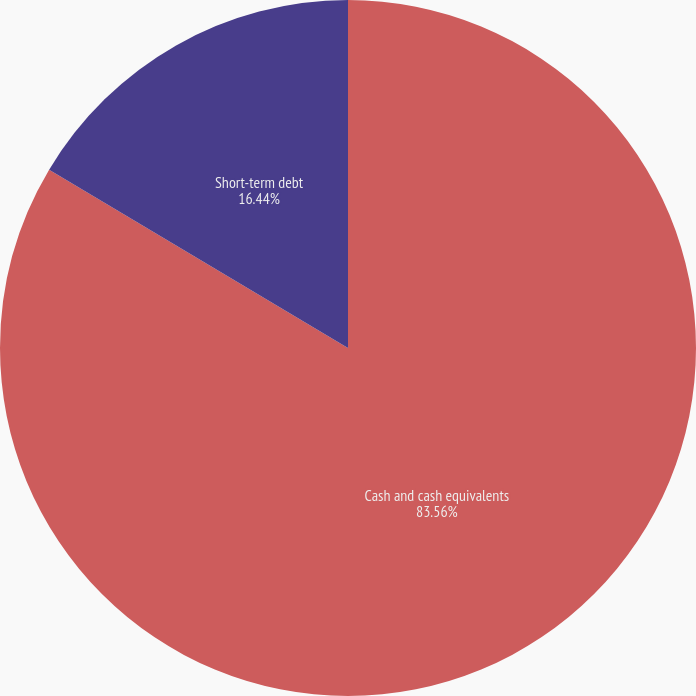Convert chart to OTSL. <chart><loc_0><loc_0><loc_500><loc_500><pie_chart><fcel>Cash and cash equivalents<fcel>Short-term debt<nl><fcel>83.56%<fcel>16.44%<nl></chart> 